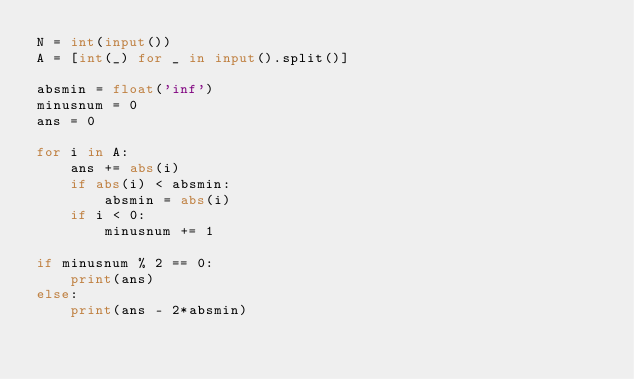<code> <loc_0><loc_0><loc_500><loc_500><_Python_>N = int(input())
A = [int(_) for _ in input().split()]

absmin = float('inf')
minusnum = 0
ans = 0

for i in A:
    ans += abs(i)
    if abs(i) < absmin:
        absmin = abs(i)
    if i < 0:
        minusnum += 1

if minusnum % 2 == 0:
    print(ans)
else:
    print(ans - 2*absmin)</code> 